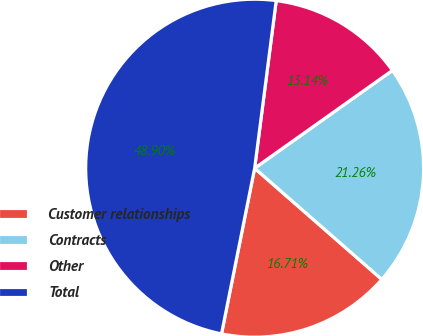Convert chart to OTSL. <chart><loc_0><loc_0><loc_500><loc_500><pie_chart><fcel>Customer relationships<fcel>Contracts<fcel>Other<fcel>Total<nl><fcel>16.71%<fcel>21.26%<fcel>13.14%<fcel>48.9%<nl></chart> 